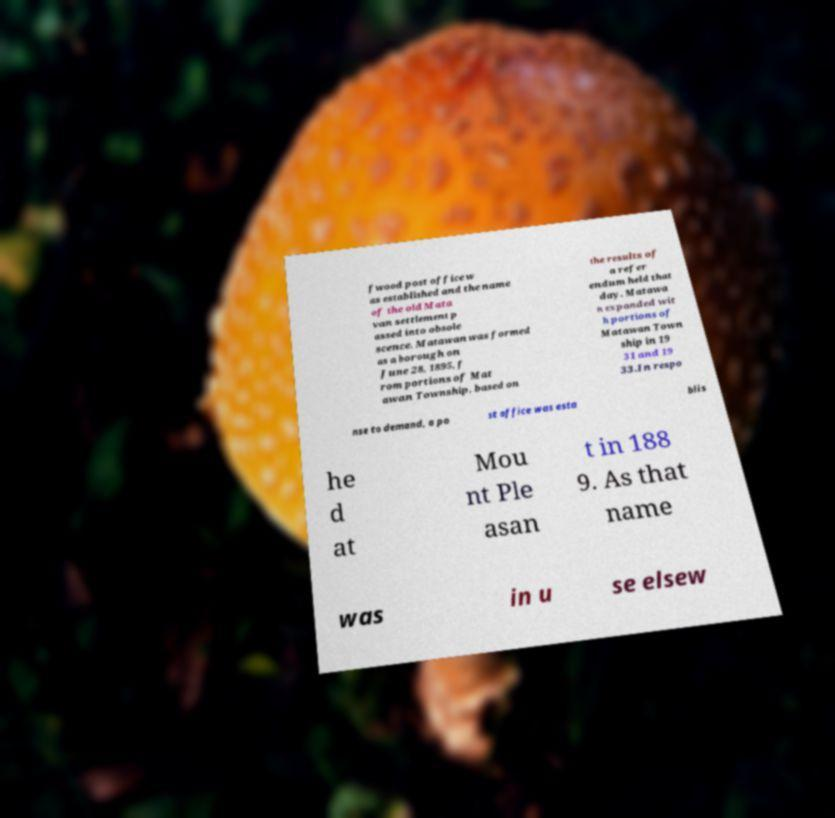Please identify and transcribe the text found in this image. fwood post office w as established and the name of the old Mata van settlement p assed into obsole scence. Matawan was formed as a borough on June 28, 1895, f rom portions of Mat awan Township, based on the results of a refer endum held that day. Matawa n expanded wit h portions of Matawan Town ship in 19 31 and 19 33.In respo nse to demand, a po st office was esta blis he d at Mou nt Ple asan t in 188 9. As that name was in u se elsew 